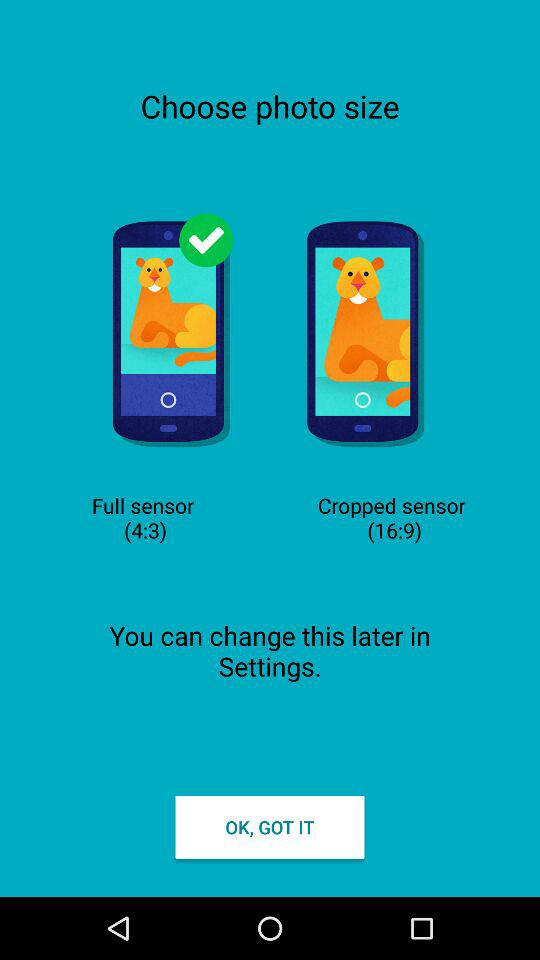Which photo size option is selected? The selected photo size option is "Full sensor (4:3)". 